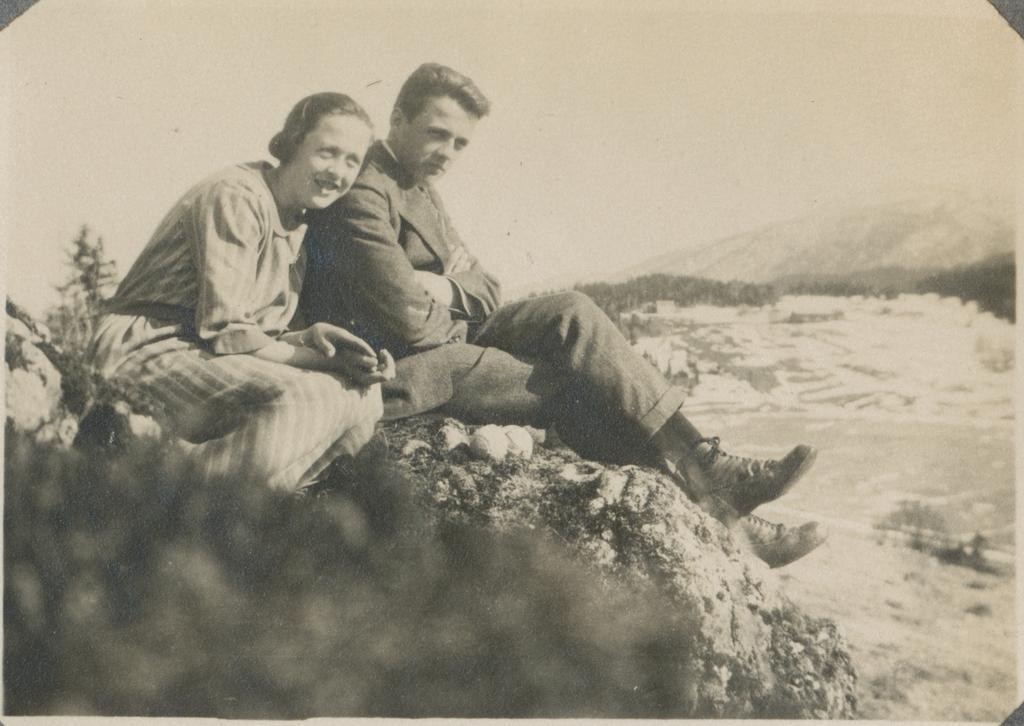In one or two sentences, can you explain what this image depicts? This image is a black and white image as we can see there are two persons sitting on the left side of this image and there is a mountain on the right side of this image. there is a sky on the top of this image. 